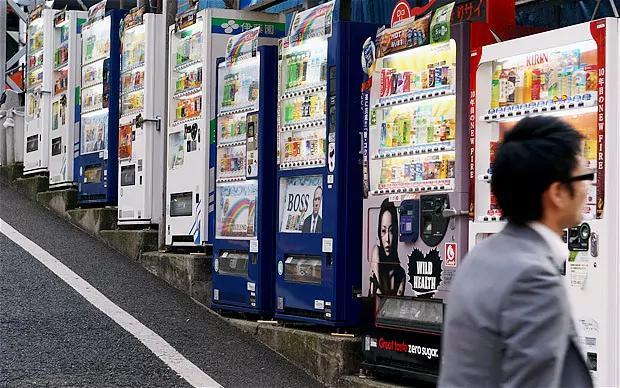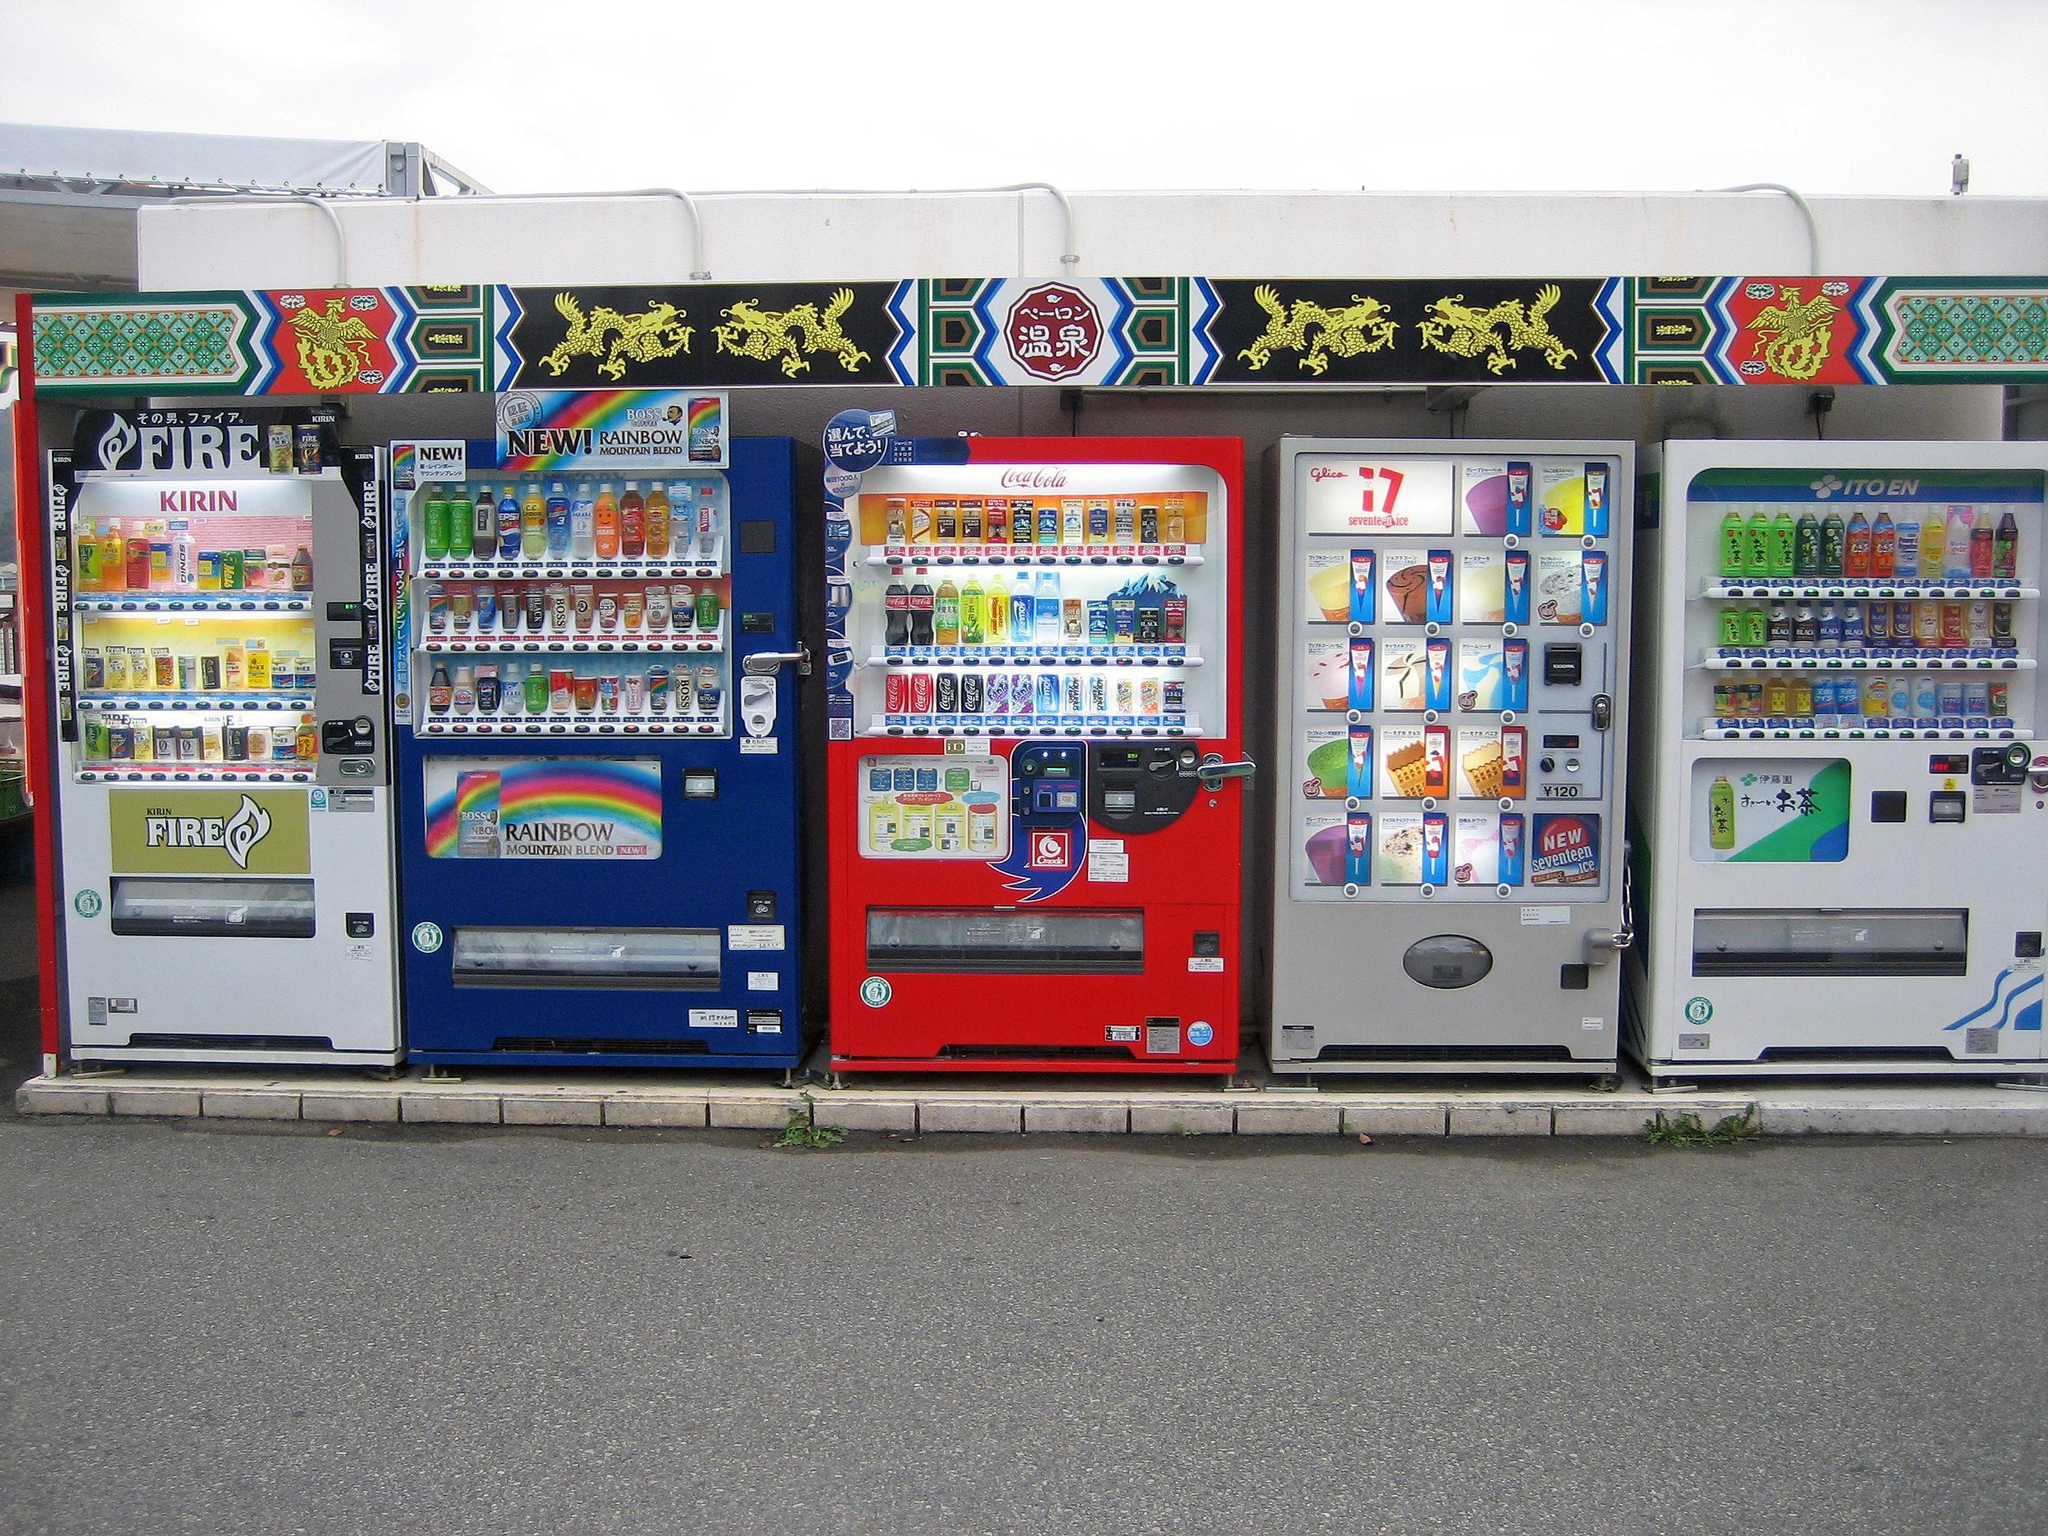The first image is the image on the left, the second image is the image on the right. Evaluate the accuracy of this statement regarding the images: "there is a person in one of the iamges.". Is it true? Answer yes or no. Yes. The first image is the image on the left, the second image is the image on the right. Considering the images on both sides, is "A dark-haired young man in a suit jacket is in the right of one image." valid? Answer yes or no. Yes. 